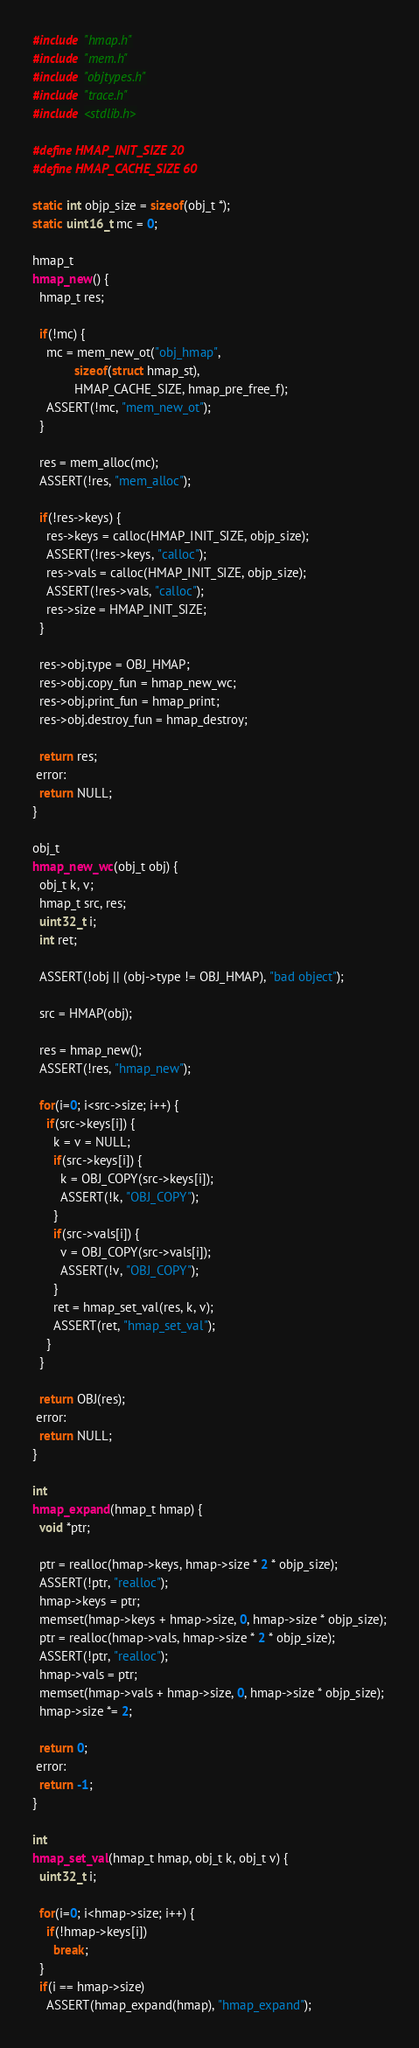<code> <loc_0><loc_0><loc_500><loc_500><_C_>#include "hmap.h"
#include "mem.h"
#include "objtypes.h"
#include "trace.h"
#include <stdlib.h>

#define HMAP_INIT_SIZE 20
#define HMAP_CACHE_SIZE 60

static int objp_size = sizeof(obj_t *);
static uint16_t mc = 0;

hmap_t
hmap_new() {
  hmap_t res;

  if(!mc) {
    mc = mem_new_ot("obj_hmap",
		    sizeof(struct hmap_st),
		    HMAP_CACHE_SIZE, hmap_pre_free_f);
    ASSERT(!mc, "mem_new_ot");
  }

  res = mem_alloc(mc);
  ASSERT(!res, "mem_alloc");

  if(!res->keys) {
    res->keys = calloc(HMAP_INIT_SIZE, objp_size);
    ASSERT(!res->keys, "calloc");
    res->vals = calloc(HMAP_INIT_SIZE, objp_size);
    ASSERT(!res->vals, "calloc");
    res->size = HMAP_INIT_SIZE;
  }

  res->obj.type = OBJ_HMAP;
  res->obj.copy_fun = hmap_new_wc;
  res->obj.print_fun = hmap_print;
  res->obj.destroy_fun = hmap_destroy;

  return res;
 error:
  return NULL;
}

obj_t
hmap_new_wc(obj_t obj) {
  obj_t k, v;
  hmap_t src, res;
  uint32_t i;
  int ret;

  ASSERT(!obj || (obj->type != OBJ_HMAP), "bad object");

  src = HMAP(obj);

  res = hmap_new();
  ASSERT(!res, "hmap_new");

  for(i=0; i<src->size; i++) {
    if(src->keys[i]) {
      k = v = NULL;
      if(src->keys[i]) {
        k = OBJ_COPY(src->keys[i]);
        ASSERT(!k, "OBJ_COPY");
      }
      if(src->vals[i]) {
        v = OBJ_COPY(src->vals[i]);
        ASSERT(!v, "OBJ_COPY");
      }
      ret = hmap_set_val(res, k, v);
      ASSERT(ret, "hmap_set_val");
    }
  }

  return OBJ(res);
 error:
  return NULL;
}

int
hmap_expand(hmap_t hmap) {
  void *ptr;

  ptr = realloc(hmap->keys, hmap->size * 2 * objp_size);
  ASSERT(!ptr, "realloc");
  hmap->keys = ptr;
  memset(hmap->keys + hmap->size, 0, hmap->size * objp_size);
  ptr = realloc(hmap->vals, hmap->size * 2 * objp_size);
  ASSERT(!ptr, "realloc");
  hmap->vals = ptr;
  memset(hmap->vals + hmap->size, 0, hmap->size * objp_size);
  hmap->size *= 2;

  return 0;
 error:
  return -1;
}

int
hmap_set_val(hmap_t hmap, obj_t k, obj_t v) {
  uint32_t i;

  for(i=0; i<hmap->size; i++) {
    if(!hmap->keys[i])
      break;
  }
  if(i == hmap->size)
    ASSERT(hmap_expand(hmap), "hmap_expand");</code> 